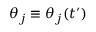<formula> <loc_0><loc_0><loc_500><loc_500>\theta _ { j } \equiv \theta _ { j } ( t ^ { \prime } )</formula> 